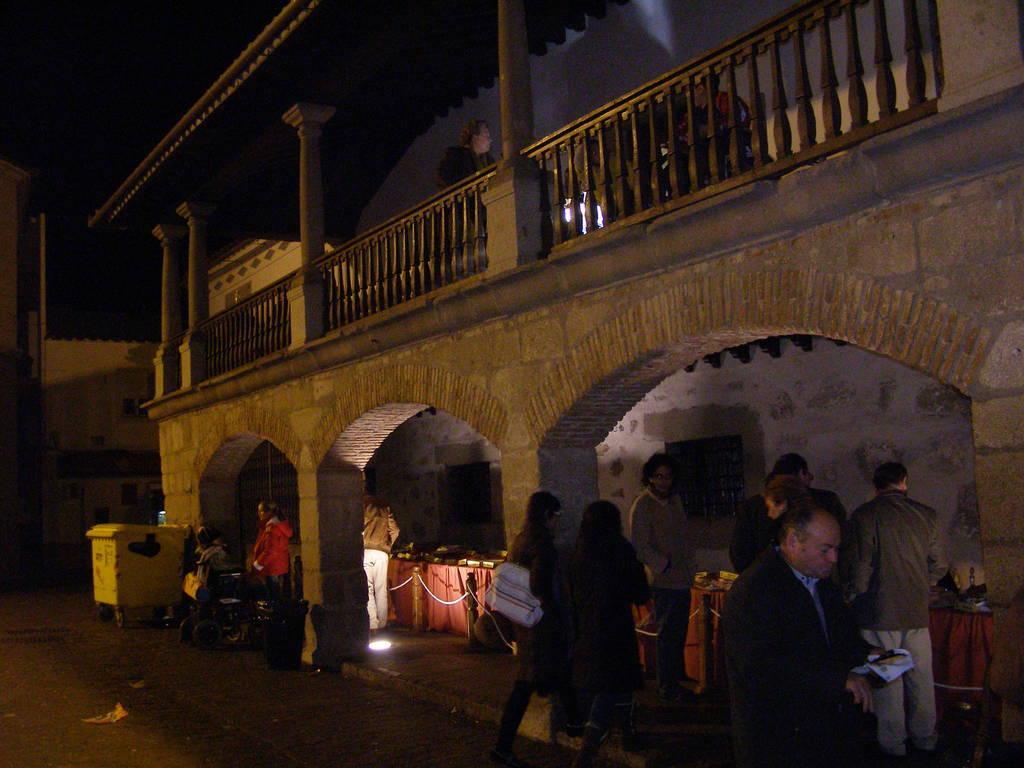Please provide a concise description of this image. In this image we can see a few people walking on the ground and a few people standing near the table, on the table we can see few objects. And we can see there are buildings with pillars and railing. There are poles with rope and a box on the ground. 